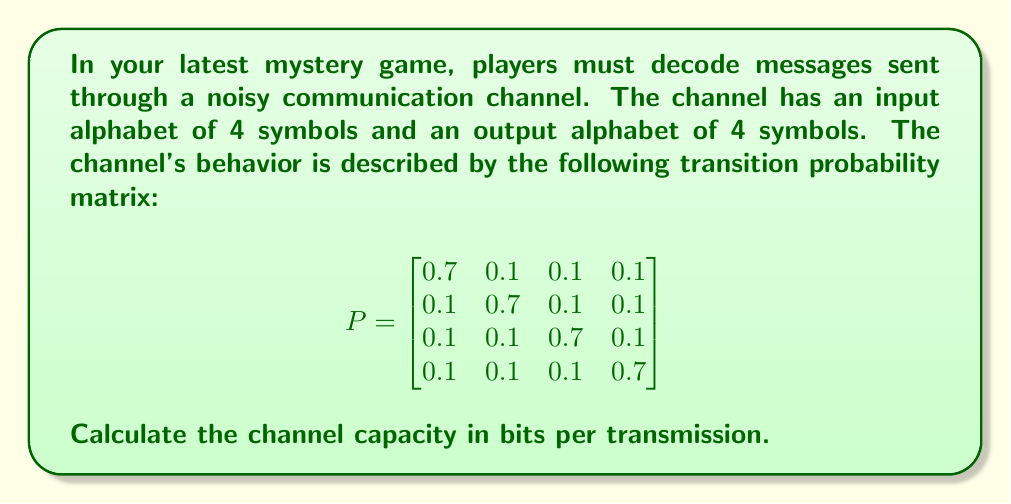Could you help me with this problem? To calculate the channel capacity, we need to follow these steps:

1) The channel capacity is given by the maximum mutual information between the input and output, maximized over all possible input distributions:

   $$C = \max_{p(x)} I(X;Y)$$

2) For a discrete memoryless channel, this can be expressed as:

   $$C = \log_2 M - \min_{p(x)} H(Y|X)$$

   where $M$ is the number of output symbols (4 in this case), and $H(Y|X)$ is the conditional entropy of Y given X.

3) In this case, the channel is symmetric (all rows of P are permutations of each other), so we know that the optimal input distribution is uniform. This means $p(x_i) = \frac{1}{4}$ for all i.

4) With a uniform input distribution, we can calculate $H(Y|X)$:

   $$H(Y|X) = -\sum_{i=1}^4 p(x_i) \sum_{j=1}^4 p(y_j|x_i) \log_2 p(y_j|x_i)$$

   $$= -4 \cdot \frac{1}{4} \cdot (0.7 \log_2 0.7 + 3 \cdot 0.1 \log_2 0.1)$$

   $$= -(0.7 \log_2 0.7 + 3 \cdot 0.1 \log_2 0.1)$$

5) Calculating this:
   
   $$H(Y|X) = -(-0.3601 - 3 \cdot 0.3322) = 1.3567$$

6) Now we can calculate the channel capacity:

   $$C = \log_2 4 - 1.3567 = 2 - 1.3567 = 0.6433$$

Therefore, the channel capacity is approximately 0.6433 bits per transmission.
Answer: 0.6433 bits per transmission 